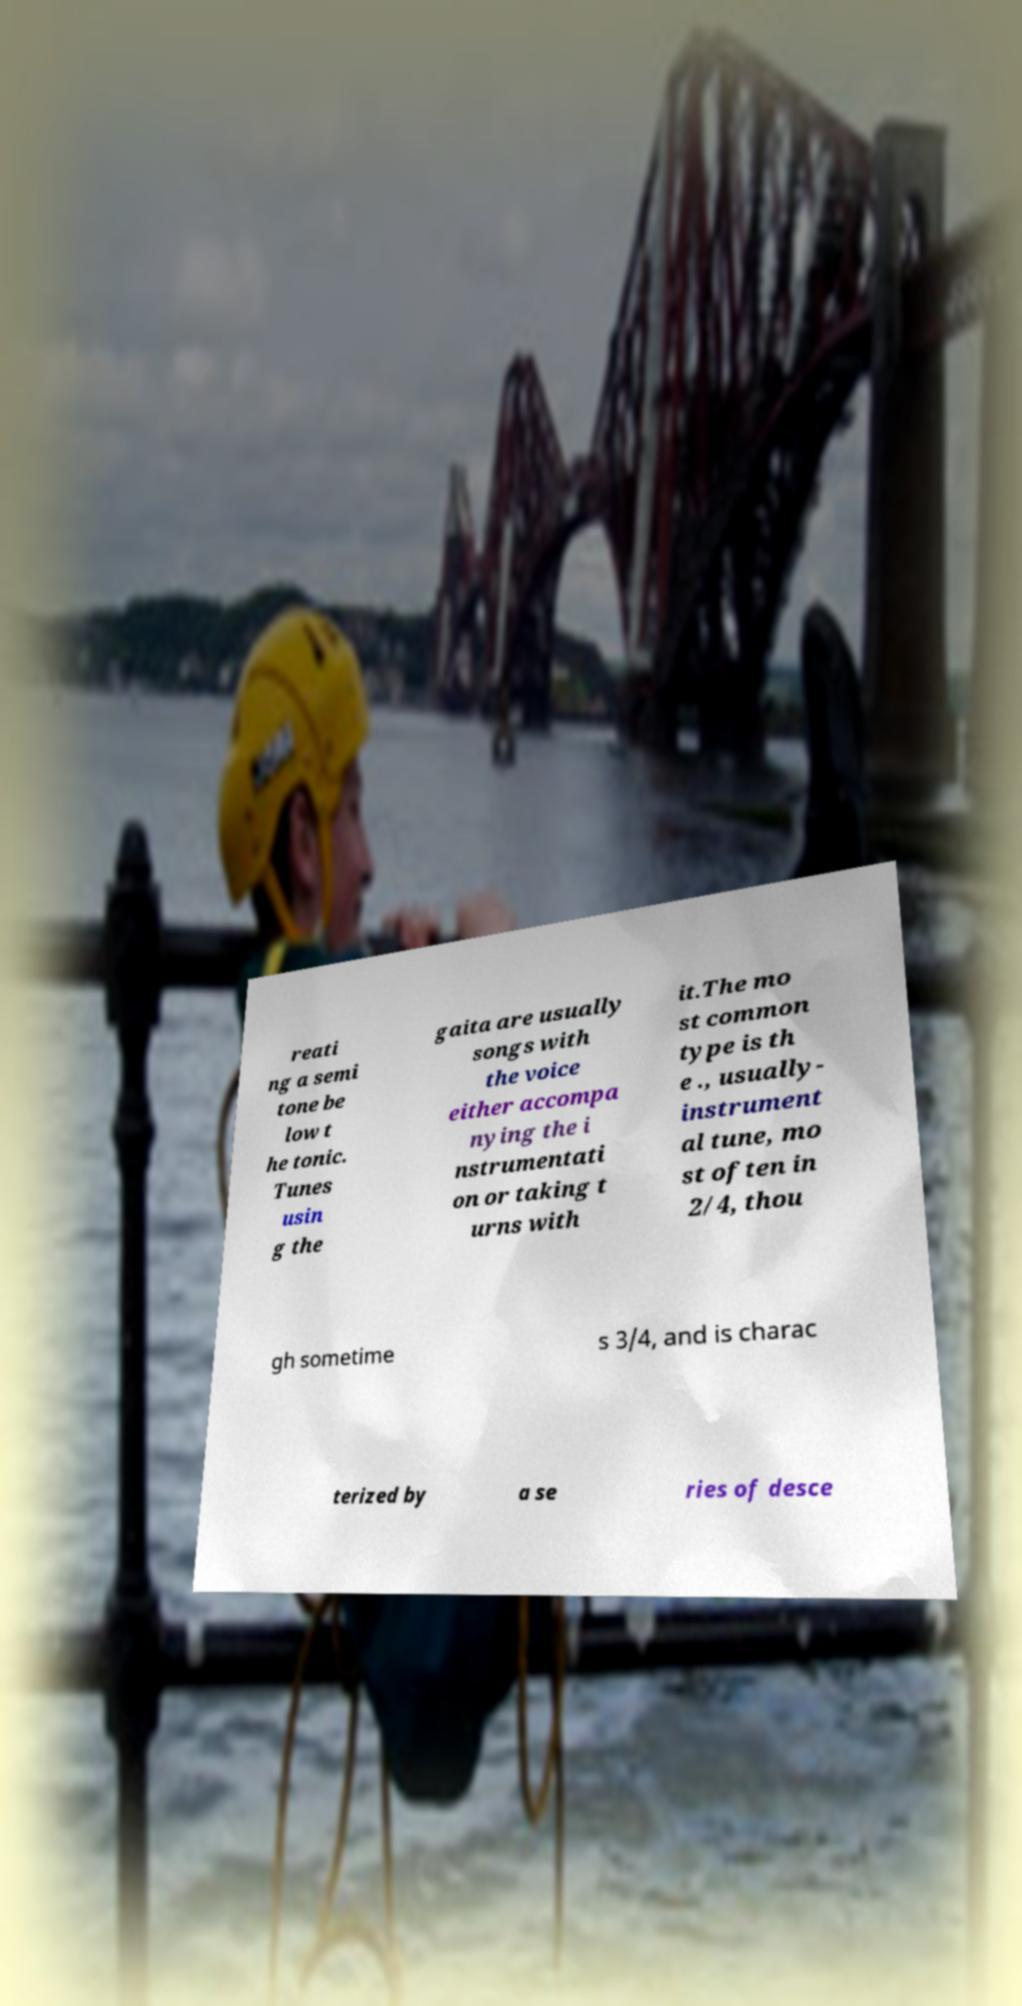Could you assist in decoding the text presented in this image and type it out clearly? reati ng a semi tone be low t he tonic. Tunes usin g the gaita are usually songs with the voice either accompa nying the i nstrumentati on or taking t urns with it.The mo st common type is th e ., usually- instrument al tune, mo st often in 2/4, thou gh sometime s 3/4, and is charac terized by a se ries of desce 